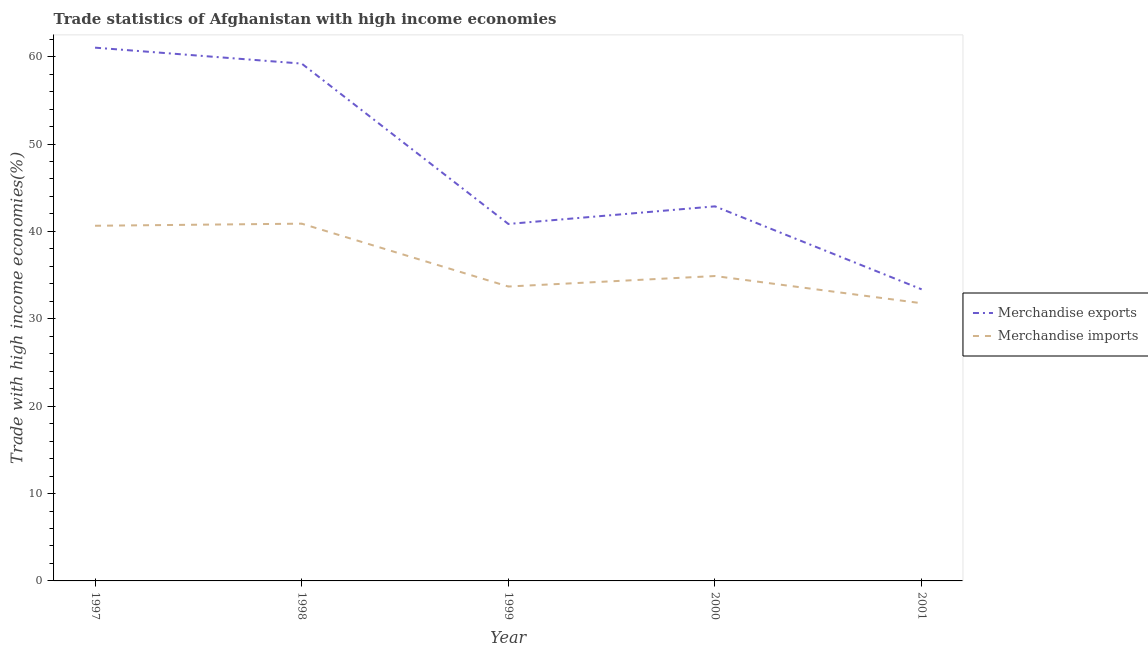How many different coloured lines are there?
Your answer should be very brief. 2. What is the merchandise imports in 1999?
Make the answer very short. 33.69. Across all years, what is the maximum merchandise exports?
Provide a succinct answer. 61.03. Across all years, what is the minimum merchandise exports?
Give a very brief answer. 33.37. In which year was the merchandise exports minimum?
Keep it short and to the point. 2001. What is the total merchandise exports in the graph?
Provide a succinct answer. 237.33. What is the difference between the merchandise imports in 1997 and that in 1999?
Keep it short and to the point. 6.95. What is the difference between the merchandise exports in 1998 and the merchandise imports in 2001?
Make the answer very short. 27.43. What is the average merchandise imports per year?
Give a very brief answer. 36.38. In the year 1998, what is the difference between the merchandise exports and merchandise imports?
Provide a short and direct response. 18.32. What is the ratio of the merchandise exports in 1997 to that in 1999?
Make the answer very short. 1.49. Is the difference between the merchandise exports in 1997 and 2000 greater than the difference between the merchandise imports in 1997 and 2000?
Your answer should be compact. Yes. What is the difference between the highest and the second highest merchandise imports?
Your response must be concise. 0.24. What is the difference between the highest and the lowest merchandise exports?
Keep it short and to the point. 27.66. In how many years, is the merchandise imports greater than the average merchandise imports taken over all years?
Offer a terse response. 2. Is the sum of the merchandise exports in 1998 and 1999 greater than the maximum merchandise imports across all years?
Your response must be concise. Yes. Is the merchandise exports strictly less than the merchandise imports over the years?
Your answer should be very brief. No. How many years are there in the graph?
Your answer should be compact. 5. How many legend labels are there?
Give a very brief answer. 2. What is the title of the graph?
Your answer should be very brief. Trade statistics of Afghanistan with high income economies. Does "Stunting" appear as one of the legend labels in the graph?
Offer a terse response. No. What is the label or title of the Y-axis?
Your answer should be very brief. Trade with high income economies(%). What is the Trade with high income economies(%) of Merchandise exports in 1997?
Your response must be concise. 61.03. What is the Trade with high income economies(%) in Merchandise imports in 1997?
Your answer should be compact. 40.65. What is the Trade with high income economies(%) of Merchandise exports in 1998?
Offer a very short reply. 59.21. What is the Trade with high income economies(%) of Merchandise imports in 1998?
Your response must be concise. 40.89. What is the Trade with high income economies(%) in Merchandise exports in 1999?
Give a very brief answer. 40.85. What is the Trade with high income economies(%) of Merchandise imports in 1999?
Offer a terse response. 33.69. What is the Trade with high income economies(%) in Merchandise exports in 2000?
Offer a terse response. 42.87. What is the Trade with high income economies(%) of Merchandise imports in 2000?
Your answer should be very brief. 34.89. What is the Trade with high income economies(%) of Merchandise exports in 2001?
Your answer should be compact. 33.37. What is the Trade with high income economies(%) of Merchandise imports in 2001?
Your answer should be very brief. 31.78. Across all years, what is the maximum Trade with high income economies(%) of Merchandise exports?
Give a very brief answer. 61.03. Across all years, what is the maximum Trade with high income economies(%) of Merchandise imports?
Provide a short and direct response. 40.89. Across all years, what is the minimum Trade with high income economies(%) in Merchandise exports?
Provide a short and direct response. 33.37. Across all years, what is the minimum Trade with high income economies(%) in Merchandise imports?
Provide a succinct answer. 31.78. What is the total Trade with high income economies(%) of Merchandise exports in the graph?
Your answer should be compact. 237.33. What is the total Trade with high income economies(%) of Merchandise imports in the graph?
Make the answer very short. 181.9. What is the difference between the Trade with high income economies(%) of Merchandise exports in 1997 and that in 1998?
Provide a succinct answer. 1.82. What is the difference between the Trade with high income economies(%) in Merchandise imports in 1997 and that in 1998?
Offer a very short reply. -0.24. What is the difference between the Trade with high income economies(%) in Merchandise exports in 1997 and that in 1999?
Your answer should be very brief. 20.18. What is the difference between the Trade with high income economies(%) of Merchandise imports in 1997 and that in 1999?
Give a very brief answer. 6.95. What is the difference between the Trade with high income economies(%) in Merchandise exports in 1997 and that in 2000?
Ensure brevity in your answer.  18.16. What is the difference between the Trade with high income economies(%) of Merchandise imports in 1997 and that in 2000?
Your response must be concise. 5.75. What is the difference between the Trade with high income economies(%) in Merchandise exports in 1997 and that in 2001?
Offer a terse response. 27.66. What is the difference between the Trade with high income economies(%) in Merchandise imports in 1997 and that in 2001?
Your answer should be very brief. 8.87. What is the difference between the Trade with high income economies(%) in Merchandise exports in 1998 and that in 1999?
Your answer should be very brief. 18.35. What is the difference between the Trade with high income economies(%) in Merchandise imports in 1998 and that in 1999?
Provide a short and direct response. 7.19. What is the difference between the Trade with high income economies(%) in Merchandise exports in 1998 and that in 2000?
Make the answer very short. 16.34. What is the difference between the Trade with high income economies(%) of Merchandise imports in 1998 and that in 2000?
Provide a short and direct response. 5.99. What is the difference between the Trade with high income economies(%) in Merchandise exports in 1998 and that in 2001?
Provide a succinct answer. 25.84. What is the difference between the Trade with high income economies(%) of Merchandise imports in 1998 and that in 2001?
Provide a short and direct response. 9.11. What is the difference between the Trade with high income economies(%) of Merchandise exports in 1999 and that in 2000?
Keep it short and to the point. -2.02. What is the difference between the Trade with high income economies(%) of Merchandise imports in 1999 and that in 2000?
Ensure brevity in your answer.  -1.2. What is the difference between the Trade with high income economies(%) of Merchandise exports in 1999 and that in 2001?
Provide a succinct answer. 7.48. What is the difference between the Trade with high income economies(%) in Merchandise imports in 1999 and that in 2001?
Offer a terse response. 1.91. What is the difference between the Trade with high income economies(%) of Merchandise exports in 2000 and that in 2001?
Your answer should be very brief. 9.5. What is the difference between the Trade with high income economies(%) of Merchandise imports in 2000 and that in 2001?
Offer a terse response. 3.11. What is the difference between the Trade with high income economies(%) of Merchandise exports in 1997 and the Trade with high income economies(%) of Merchandise imports in 1998?
Provide a short and direct response. 20.14. What is the difference between the Trade with high income economies(%) in Merchandise exports in 1997 and the Trade with high income economies(%) in Merchandise imports in 1999?
Provide a succinct answer. 27.34. What is the difference between the Trade with high income economies(%) of Merchandise exports in 1997 and the Trade with high income economies(%) of Merchandise imports in 2000?
Offer a very short reply. 26.14. What is the difference between the Trade with high income economies(%) of Merchandise exports in 1997 and the Trade with high income economies(%) of Merchandise imports in 2001?
Your answer should be very brief. 29.25. What is the difference between the Trade with high income economies(%) of Merchandise exports in 1998 and the Trade with high income economies(%) of Merchandise imports in 1999?
Keep it short and to the point. 25.51. What is the difference between the Trade with high income economies(%) in Merchandise exports in 1998 and the Trade with high income economies(%) in Merchandise imports in 2000?
Make the answer very short. 24.31. What is the difference between the Trade with high income economies(%) in Merchandise exports in 1998 and the Trade with high income economies(%) in Merchandise imports in 2001?
Ensure brevity in your answer.  27.43. What is the difference between the Trade with high income economies(%) of Merchandise exports in 1999 and the Trade with high income economies(%) of Merchandise imports in 2000?
Offer a terse response. 5.96. What is the difference between the Trade with high income economies(%) in Merchandise exports in 1999 and the Trade with high income economies(%) in Merchandise imports in 2001?
Give a very brief answer. 9.07. What is the difference between the Trade with high income economies(%) in Merchandise exports in 2000 and the Trade with high income economies(%) in Merchandise imports in 2001?
Keep it short and to the point. 11.09. What is the average Trade with high income economies(%) in Merchandise exports per year?
Offer a terse response. 47.47. What is the average Trade with high income economies(%) in Merchandise imports per year?
Provide a short and direct response. 36.38. In the year 1997, what is the difference between the Trade with high income economies(%) of Merchandise exports and Trade with high income economies(%) of Merchandise imports?
Offer a very short reply. 20.38. In the year 1998, what is the difference between the Trade with high income economies(%) in Merchandise exports and Trade with high income economies(%) in Merchandise imports?
Provide a succinct answer. 18.32. In the year 1999, what is the difference between the Trade with high income economies(%) of Merchandise exports and Trade with high income economies(%) of Merchandise imports?
Your answer should be compact. 7.16. In the year 2000, what is the difference between the Trade with high income economies(%) in Merchandise exports and Trade with high income economies(%) in Merchandise imports?
Your response must be concise. 7.98. In the year 2001, what is the difference between the Trade with high income economies(%) in Merchandise exports and Trade with high income economies(%) in Merchandise imports?
Your answer should be very brief. 1.59. What is the ratio of the Trade with high income economies(%) in Merchandise exports in 1997 to that in 1998?
Offer a very short reply. 1.03. What is the ratio of the Trade with high income economies(%) in Merchandise exports in 1997 to that in 1999?
Your answer should be very brief. 1.49. What is the ratio of the Trade with high income economies(%) in Merchandise imports in 1997 to that in 1999?
Make the answer very short. 1.21. What is the ratio of the Trade with high income economies(%) of Merchandise exports in 1997 to that in 2000?
Provide a succinct answer. 1.42. What is the ratio of the Trade with high income economies(%) in Merchandise imports in 1997 to that in 2000?
Keep it short and to the point. 1.16. What is the ratio of the Trade with high income economies(%) of Merchandise exports in 1997 to that in 2001?
Ensure brevity in your answer.  1.83. What is the ratio of the Trade with high income economies(%) of Merchandise imports in 1997 to that in 2001?
Offer a terse response. 1.28. What is the ratio of the Trade with high income economies(%) in Merchandise exports in 1998 to that in 1999?
Provide a short and direct response. 1.45. What is the ratio of the Trade with high income economies(%) in Merchandise imports in 1998 to that in 1999?
Give a very brief answer. 1.21. What is the ratio of the Trade with high income economies(%) in Merchandise exports in 1998 to that in 2000?
Make the answer very short. 1.38. What is the ratio of the Trade with high income economies(%) of Merchandise imports in 1998 to that in 2000?
Offer a very short reply. 1.17. What is the ratio of the Trade with high income economies(%) of Merchandise exports in 1998 to that in 2001?
Ensure brevity in your answer.  1.77. What is the ratio of the Trade with high income economies(%) in Merchandise imports in 1998 to that in 2001?
Keep it short and to the point. 1.29. What is the ratio of the Trade with high income economies(%) of Merchandise exports in 1999 to that in 2000?
Provide a succinct answer. 0.95. What is the ratio of the Trade with high income economies(%) of Merchandise imports in 1999 to that in 2000?
Your response must be concise. 0.97. What is the ratio of the Trade with high income economies(%) of Merchandise exports in 1999 to that in 2001?
Offer a terse response. 1.22. What is the ratio of the Trade with high income economies(%) in Merchandise imports in 1999 to that in 2001?
Your answer should be very brief. 1.06. What is the ratio of the Trade with high income economies(%) of Merchandise exports in 2000 to that in 2001?
Offer a terse response. 1.28. What is the ratio of the Trade with high income economies(%) in Merchandise imports in 2000 to that in 2001?
Your answer should be compact. 1.1. What is the difference between the highest and the second highest Trade with high income economies(%) in Merchandise exports?
Provide a short and direct response. 1.82. What is the difference between the highest and the second highest Trade with high income economies(%) in Merchandise imports?
Your response must be concise. 0.24. What is the difference between the highest and the lowest Trade with high income economies(%) in Merchandise exports?
Your answer should be compact. 27.66. What is the difference between the highest and the lowest Trade with high income economies(%) in Merchandise imports?
Your answer should be compact. 9.11. 